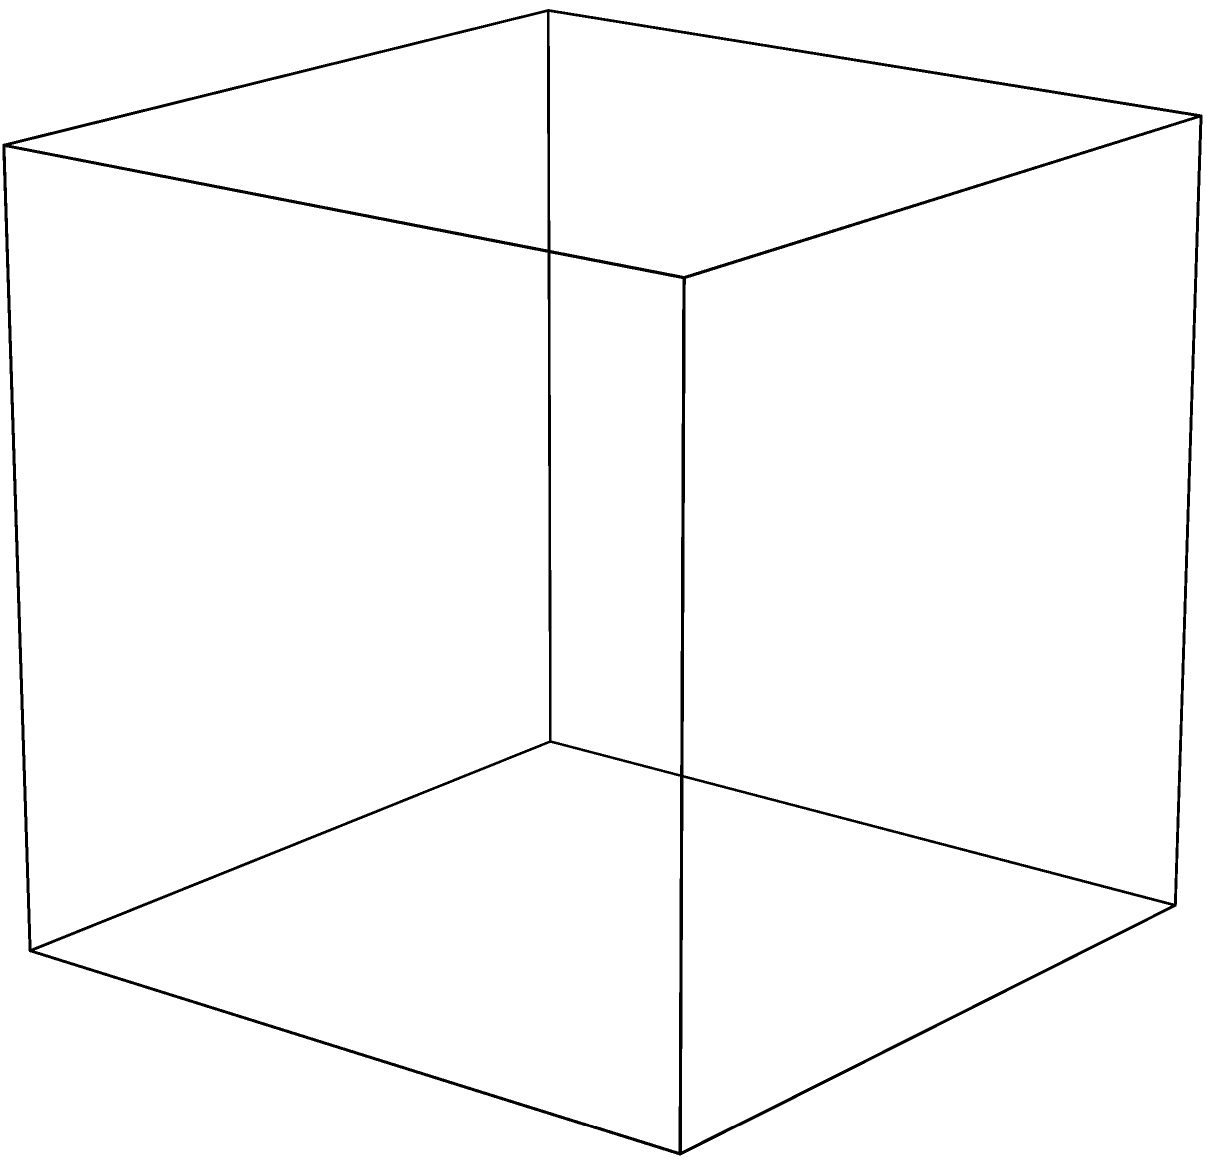As a government employee who has experienced budget cuts, you understand the importance of efficient resource allocation. In a similar vein, identifying the correct unfolded pattern of a 3D object is crucial for efficient packaging and storage. Which of the three unfolded patterns shown (A, B, or C) corresponds to the cube depicted on the left? To solve this problem, we need to analyze the cube and the given unfolded patterns step-by-step:

1. Observe the cube: It has six faces, each connected to four others.

2. Analyze the unfolded patterns:
   - Pattern A (top right): Has six squares arranged in a cross shape.
   - Pattern B (bottom right): Has six squares arranged in a T shape.
   - Pattern C (bottom left): Has six squares arranged in a long strip.

3. Visualize folding:
   - For Pattern A: The four squares in a line would form the sides, with top and bottom squares folding to complete the cube.
   - For Pattern B: The four squares in a T shape would form three sides and the bottom, with the two extending squares folding up to form the remaining sides.
   - For Pattern C: The six squares in a line cannot fold into a cube without overlapping.

4. Check connectivity:
   - Pattern A: Each face is connected to the correct adjacent faces.
   - Pattern B: The faces are not connected correctly to form a cube.
   - Pattern C: The faces are not arranged in a way that can form a cube.

5. Conclusion: Pattern A is the only one that can be folded to form the given cube.

This process of visualization and analysis is similar to how we might approach resource allocation in government, considering all aspects and connections before making a decision.
Answer: A 